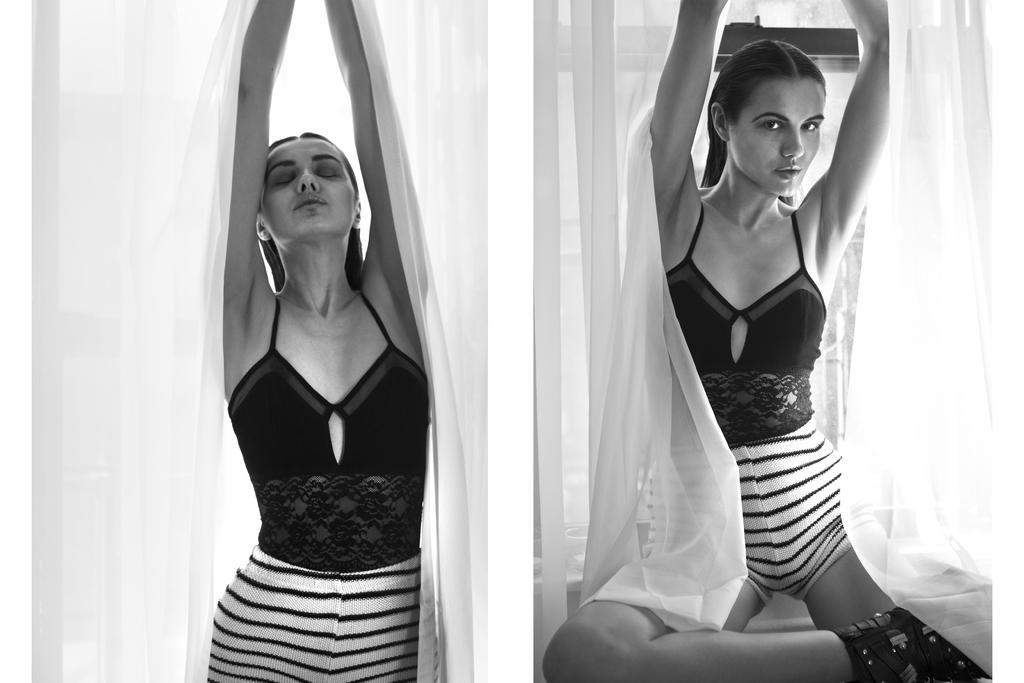How would you summarize this image in a sentence or two? It is a collage picture. We can see similar women giving different postures. Here we can see curtains. It is a black and white image. 